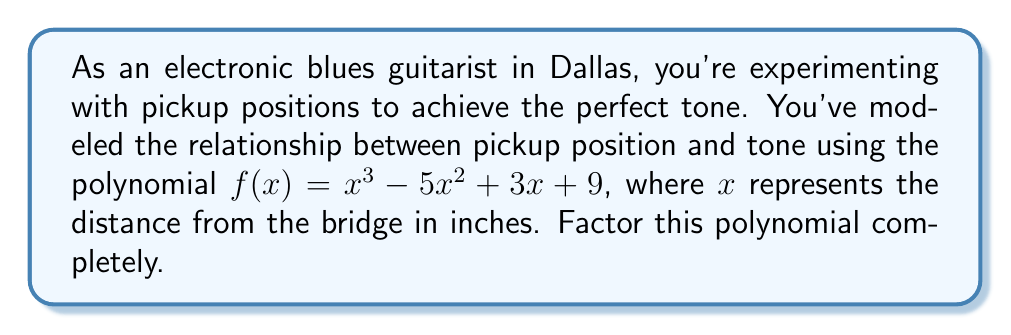Can you answer this question? To factor this polynomial, we'll follow these steps:

1) First, let's check if there are any rational roots using the rational root theorem. The possible rational roots are the factors of the constant term (9): ±1, ±3, ±9.

2) Testing these values, we find that $f(-1) = 0$. So $(x+1)$ is a factor.

3) We can use polynomial long division to divide $f(x)$ by $(x+1)$:

   $x^3 - 5x^2 + 3x + 9 = (x+1)(x^2 - 6x + 9)$

4) Now we need to factor the quadratic term $x^2 - 6x + 9$. We can do this by recognizing it as a perfect square trinomial:

   $x^2 - 6x + 9 = (x - 3)^2$

5) Therefore, the complete factorization is:

   $f(x) = (x+1)(x-3)^2$

This factorization shows that the tone function has a single root at $x=-1$ and a double root at $x=3$.
Answer: $f(x) = (x+1)(x-3)^2$ 